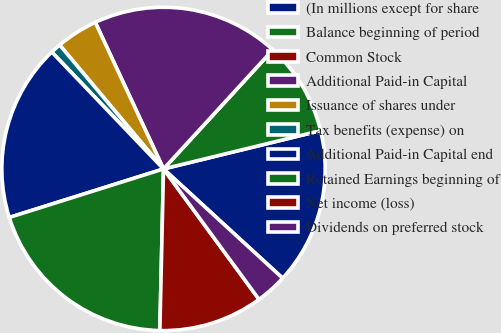Convert chart. <chart><loc_0><loc_0><loc_500><loc_500><pie_chart><fcel>(In millions except for share<fcel>Balance beginning of period<fcel>Common Stock<fcel>Additional Paid-in Capital<fcel>Issuance of shares under<fcel>Tax benefits (expense) on<fcel>Additional Paid-in Capital end<fcel>Retained Earnings beginning of<fcel>Net income (loss)<fcel>Dividends on preferred stock<nl><fcel>15.62%<fcel>9.38%<fcel>0.0%<fcel>18.75%<fcel>4.17%<fcel>1.04%<fcel>17.71%<fcel>19.79%<fcel>10.42%<fcel>3.13%<nl></chart> 